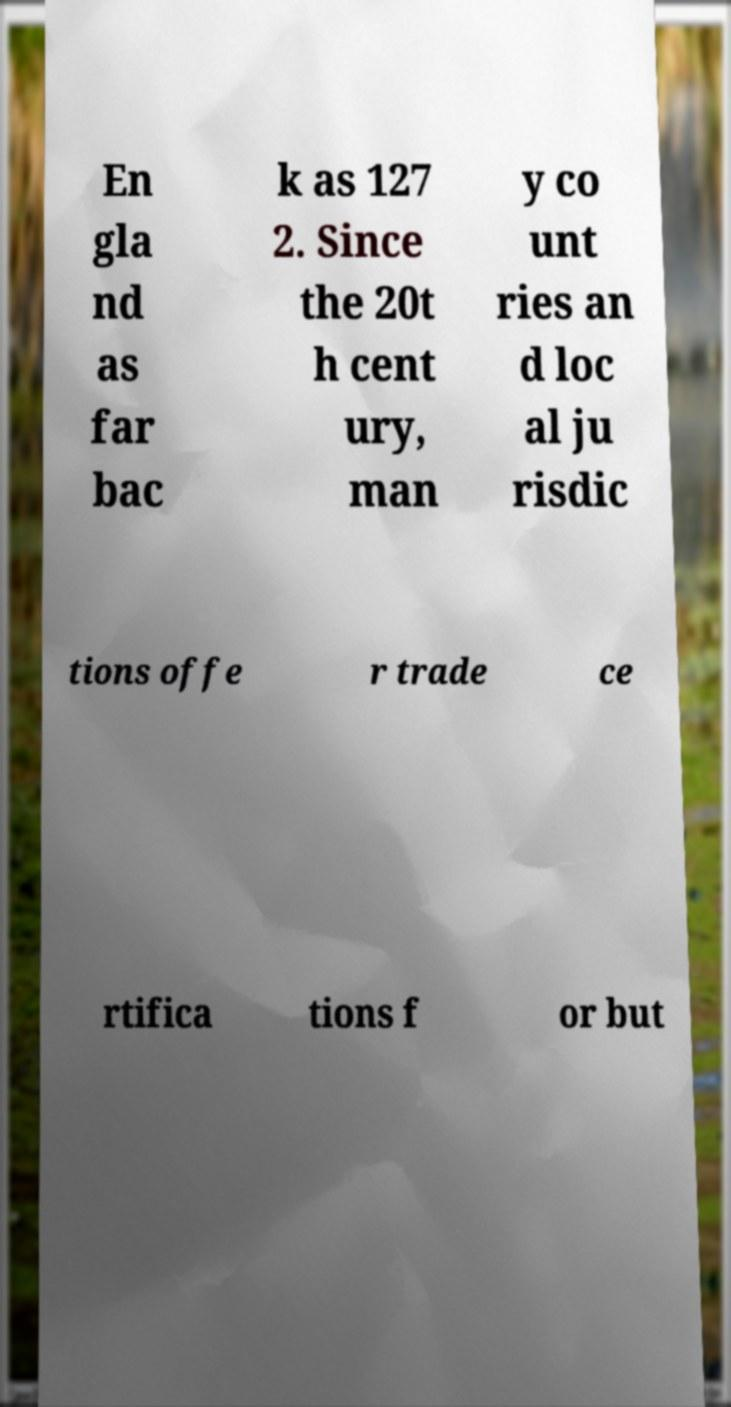Please read and relay the text visible in this image. What does it say? En gla nd as far bac k as 127 2. Since the 20t h cent ury, man y co unt ries an d loc al ju risdic tions offe r trade ce rtifica tions f or but 